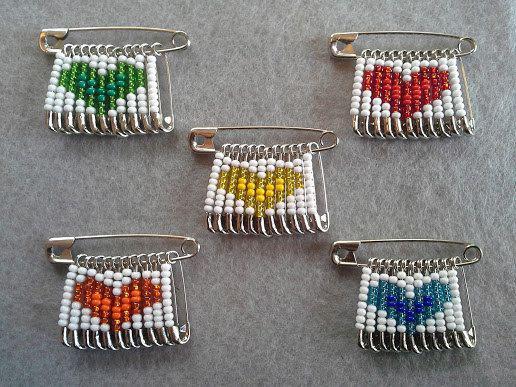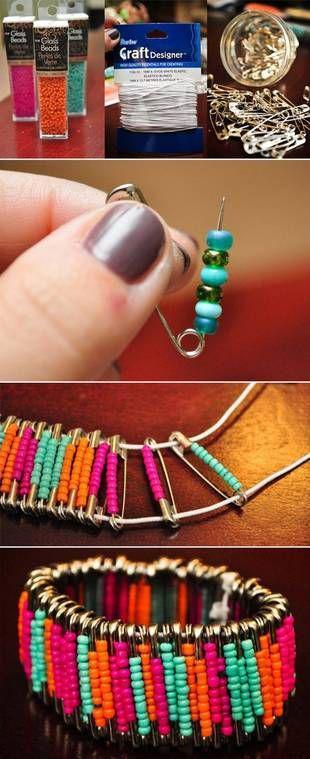The first image is the image on the left, the second image is the image on the right. Evaluate the accuracy of this statement regarding the images: "Some safety pins are strung with beads that create heart shapes.". Is it true? Answer yes or no. Yes. The first image is the image on the left, the second image is the image on the right. Evaluate the accuracy of this statement regarding the images: "The pins in the image on the left show hearts.". Is it true? Answer yes or no. Yes. 